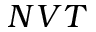Convert formula to latex. <formula><loc_0><loc_0><loc_500><loc_500>N V T</formula> 